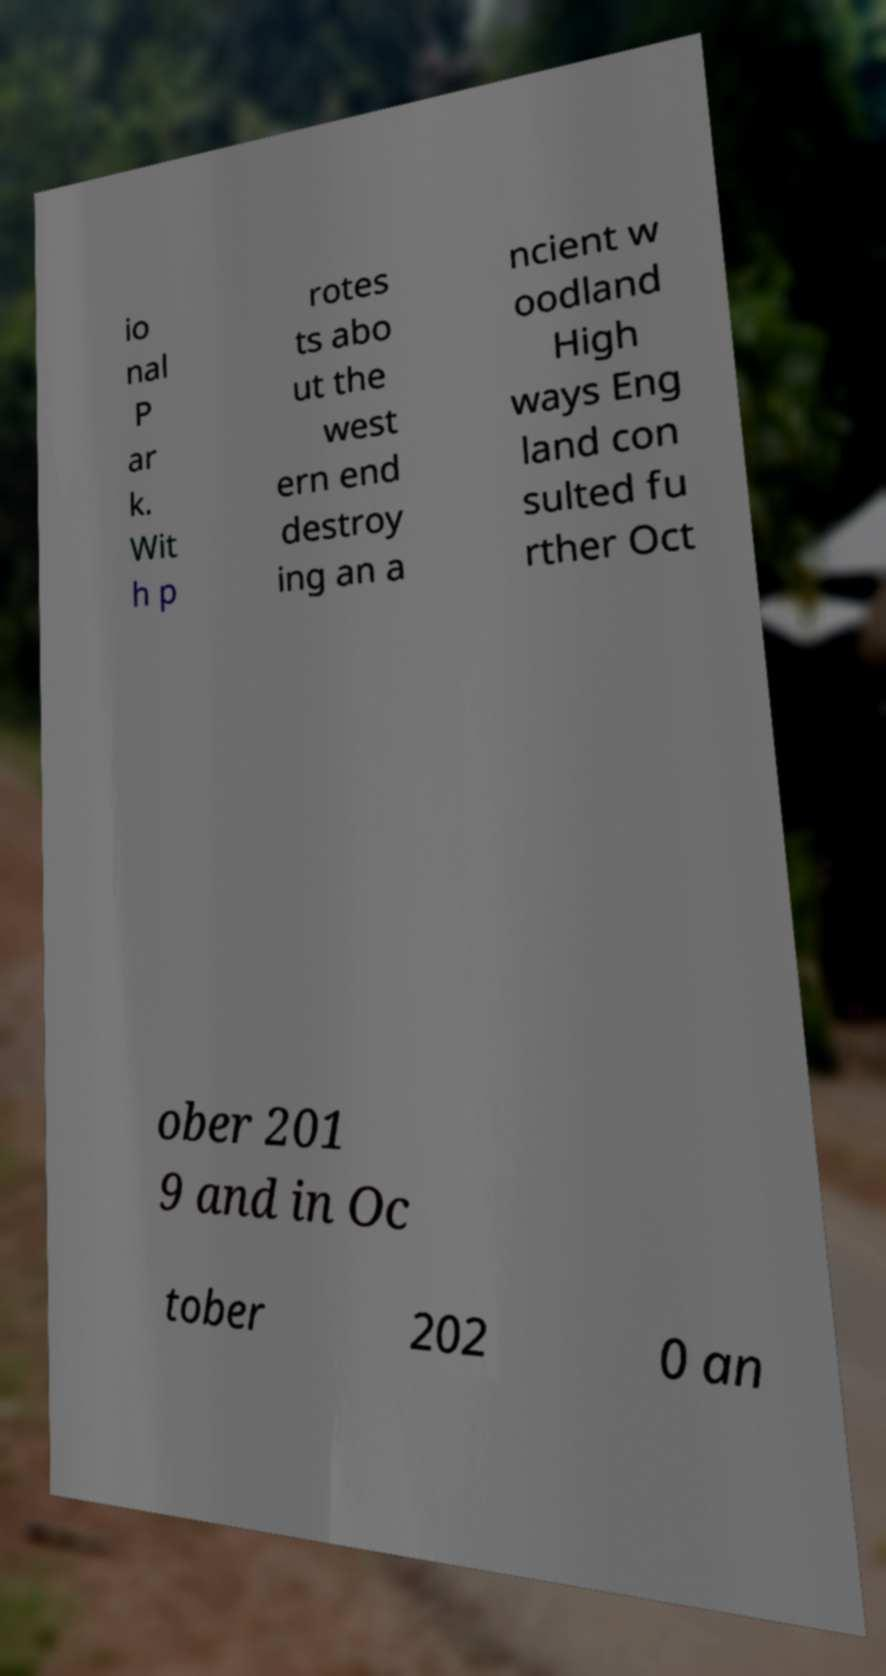Could you extract and type out the text from this image? io nal P ar k. Wit h p rotes ts abo ut the west ern end destroy ing an a ncient w oodland High ways Eng land con sulted fu rther Oct ober 201 9 and in Oc tober 202 0 an 